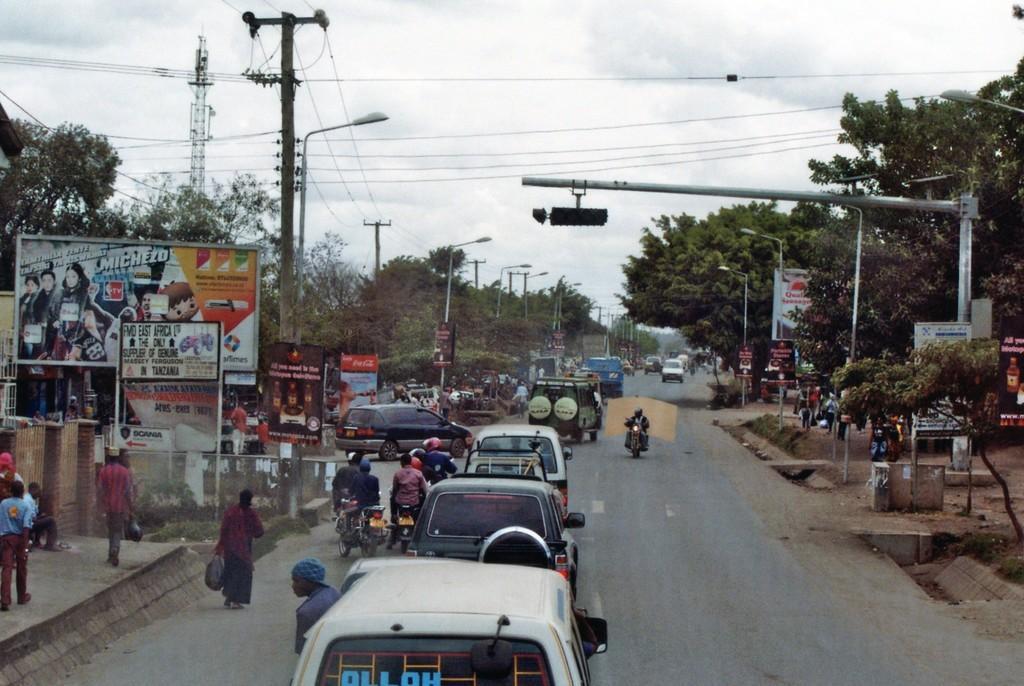In one or two sentences, can you explain what this image depicts? In the foreground of the image we can see group of vehicles parked on the road, some persons are riding motorcycles. On the left side of the image we can see group of persons standing on the ground, some sign boards with text. To the right side of the image we can see traffic lights on a pole, group of light poles. In the background, we can see a pole with some cables, group of trees and the sky. 